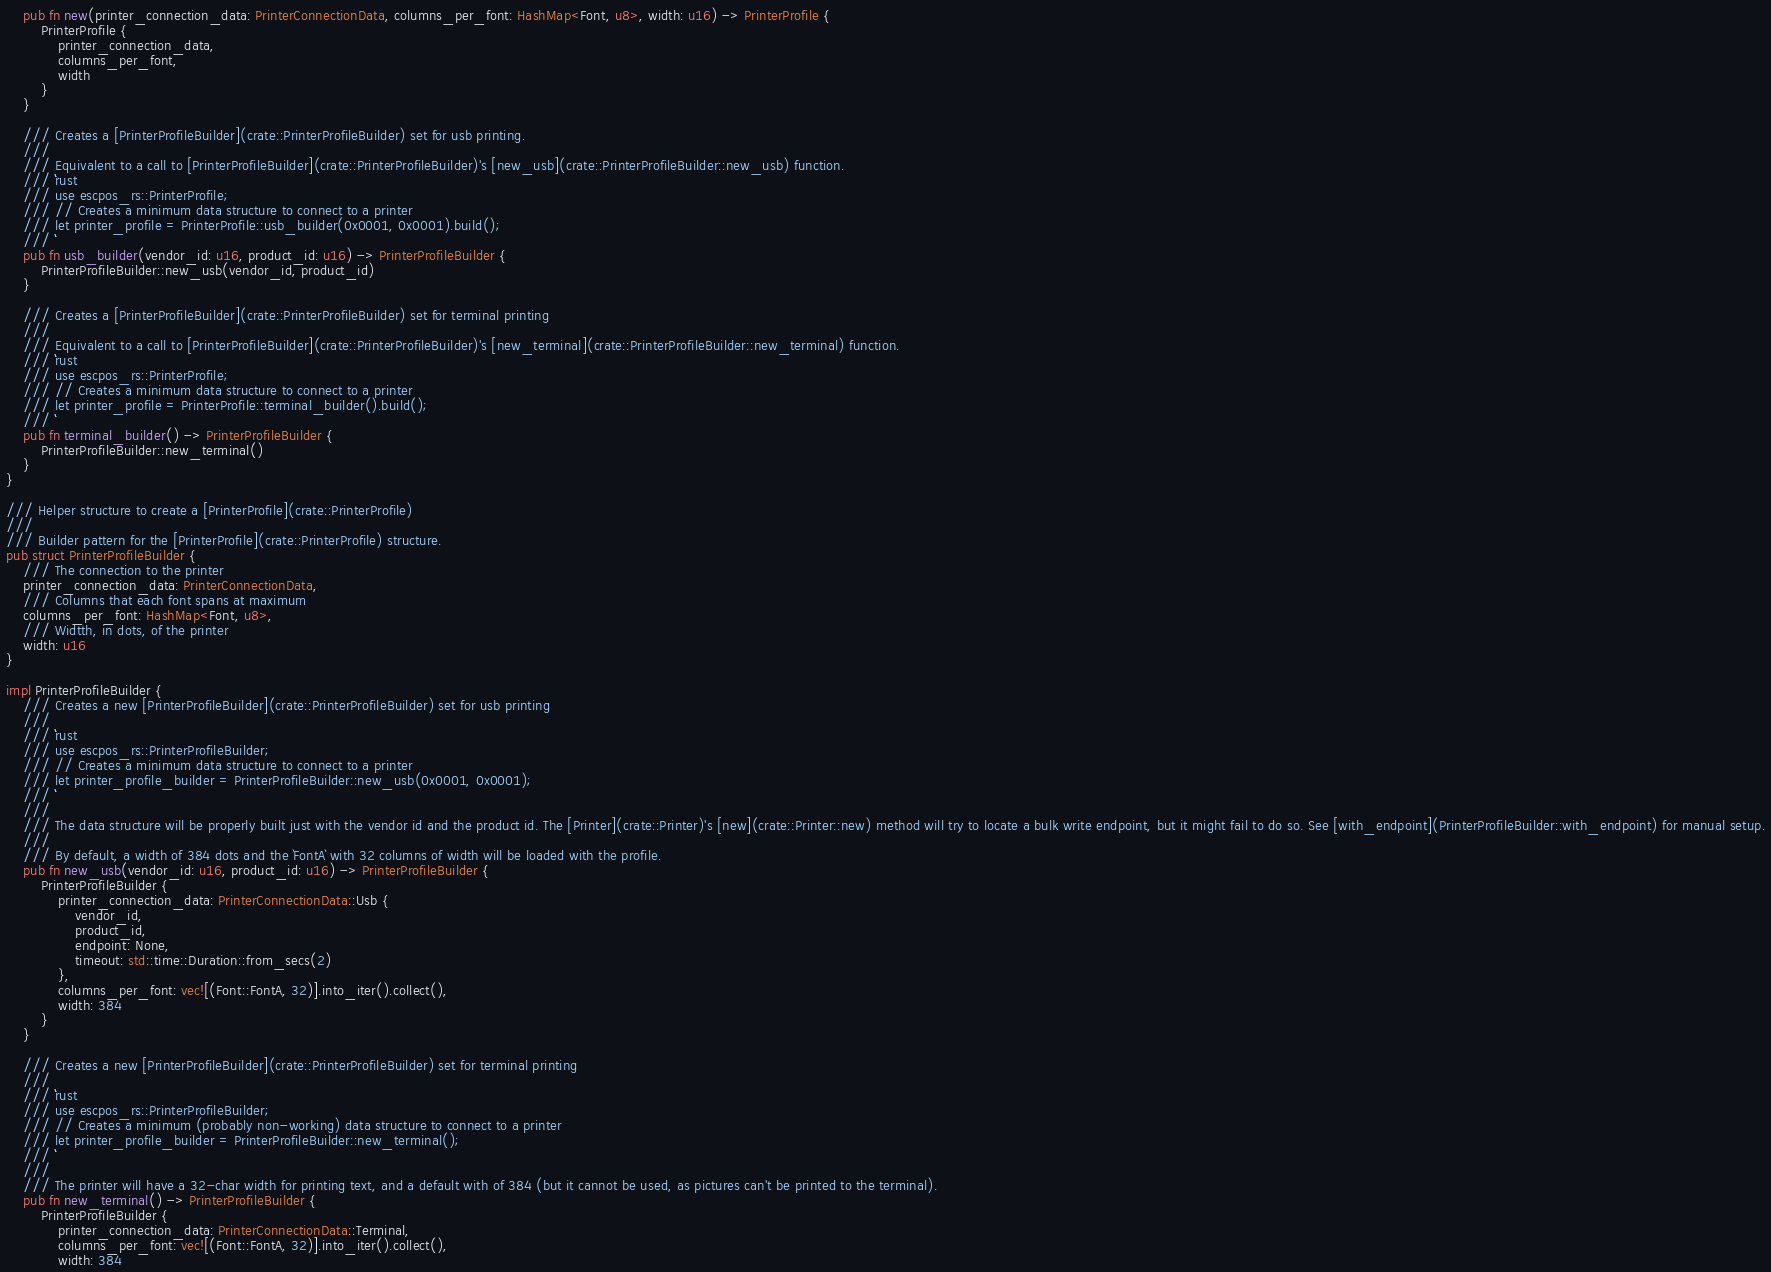<code> <loc_0><loc_0><loc_500><loc_500><_Rust_>    pub fn new(printer_connection_data: PrinterConnectionData, columns_per_font: HashMap<Font, u8>, width: u16) -> PrinterProfile {
        PrinterProfile {
            printer_connection_data,
            columns_per_font,
            width
        }
    }

    /// Creates a [PrinterProfileBuilder](crate::PrinterProfileBuilder) set for usb printing.
    ///
    /// Equivalent to a call to [PrinterProfileBuilder](crate::PrinterProfileBuilder)'s [new_usb](crate::PrinterProfileBuilder::new_usb) function.
    /// ```rust
    /// use escpos_rs::PrinterProfile;
    /// // Creates a minimum data structure to connect to a printer
    /// let printer_profile = PrinterProfile::usb_builder(0x0001, 0x0001).build();
    /// ```
    pub fn usb_builder(vendor_id: u16, product_id: u16) -> PrinterProfileBuilder {
        PrinterProfileBuilder::new_usb(vendor_id, product_id)
    }

    /// Creates a [PrinterProfileBuilder](crate::PrinterProfileBuilder) set for terminal printing
    ///
    /// Equivalent to a call to [PrinterProfileBuilder](crate::PrinterProfileBuilder)'s [new_terminal](crate::PrinterProfileBuilder::new_terminal) function.
    /// ```rust
    /// use escpos_rs::PrinterProfile;
    /// // Creates a minimum data structure to connect to a printer
    /// let printer_profile = PrinterProfile::terminal_builder().build();
    /// ```
    pub fn terminal_builder() -> PrinterProfileBuilder {
        PrinterProfileBuilder::new_terminal()
    }
}

/// Helper structure to create a [PrinterProfile](crate::PrinterProfile)
///
/// Builder pattern for the [PrinterProfile](crate::PrinterProfile) structure.
pub struct PrinterProfileBuilder {
    /// The connection to the printer
    printer_connection_data: PrinterConnectionData,
    /// Columns that each font spans at maximum
    columns_per_font: HashMap<Font, u8>,
    /// Widtth, in dots, of the printer
    width: u16
}

impl PrinterProfileBuilder {
    /// Creates a new [PrinterProfileBuilder](crate::PrinterProfileBuilder) set for usb printing
    ///
    /// ```rust
    /// use escpos_rs::PrinterProfileBuilder;
    /// // Creates a minimum data structure to connect to a printer
    /// let printer_profile_builder = PrinterProfileBuilder::new_usb(0x0001, 0x0001);
    /// ```
    ///
    /// The data structure will be properly built just with the vendor id and the product id. The [Printer](crate::Printer)'s [new](crate::Printer::new) method will try to locate a bulk write endpoint, but it might fail to do so. See [with_endpoint](PrinterProfileBuilder::with_endpoint) for manual setup.
    ///
    /// By default, a width of 384 dots and the `FontA` with 32 columns of width will be loaded with the profile.
    pub fn new_usb(vendor_id: u16, product_id: u16) -> PrinterProfileBuilder {
        PrinterProfileBuilder {
            printer_connection_data: PrinterConnectionData::Usb {
                vendor_id,
                product_id,
                endpoint: None,
                timeout: std::time::Duration::from_secs(2)
            },
            columns_per_font: vec![(Font::FontA, 32)].into_iter().collect(),
            width: 384
        }
    }

    /// Creates a new [PrinterProfileBuilder](crate::PrinterProfileBuilder) set for terminal printing
    ///
    /// ```rust
    /// use escpos_rs::PrinterProfileBuilder;
    /// // Creates a minimum (probably non-working) data structure to connect to a printer
    /// let printer_profile_builder = PrinterProfileBuilder::new_terminal();
    /// ```
    ///
    /// The printer will have a 32-char width for printing text, and a default with of 384 (but it cannot be used, as pictures can't be printed to the terminal).
    pub fn new_terminal() -> PrinterProfileBuilder {
        PrinterProfileBuilder {
            printer_connection_data: PrinterConnectionData::Terminal,
            columns_per_font: vec![(Font::FontA, 32)].into_iter().collect(),
            width: 384</code> 